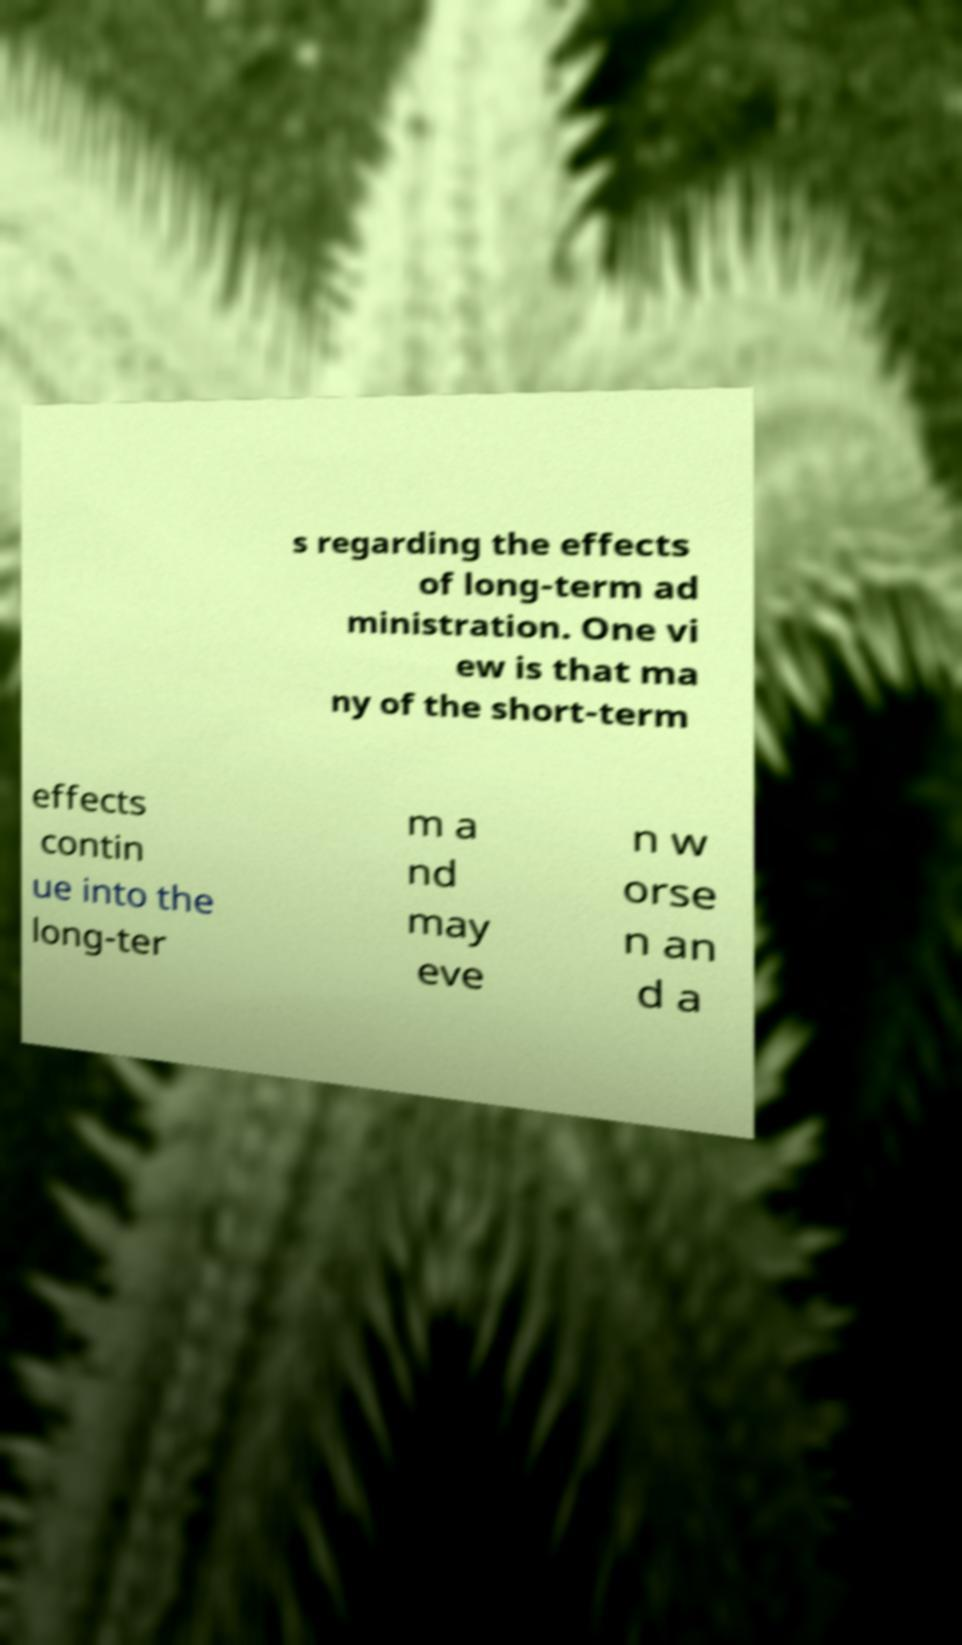Please read and relay the text visible in this image. What does it say? s regarding the effects of long-term ad ministration. One vi ew is that ma ny of the short-term effects contin ue into the long-ter m a nd may eve n w orse n an d a 